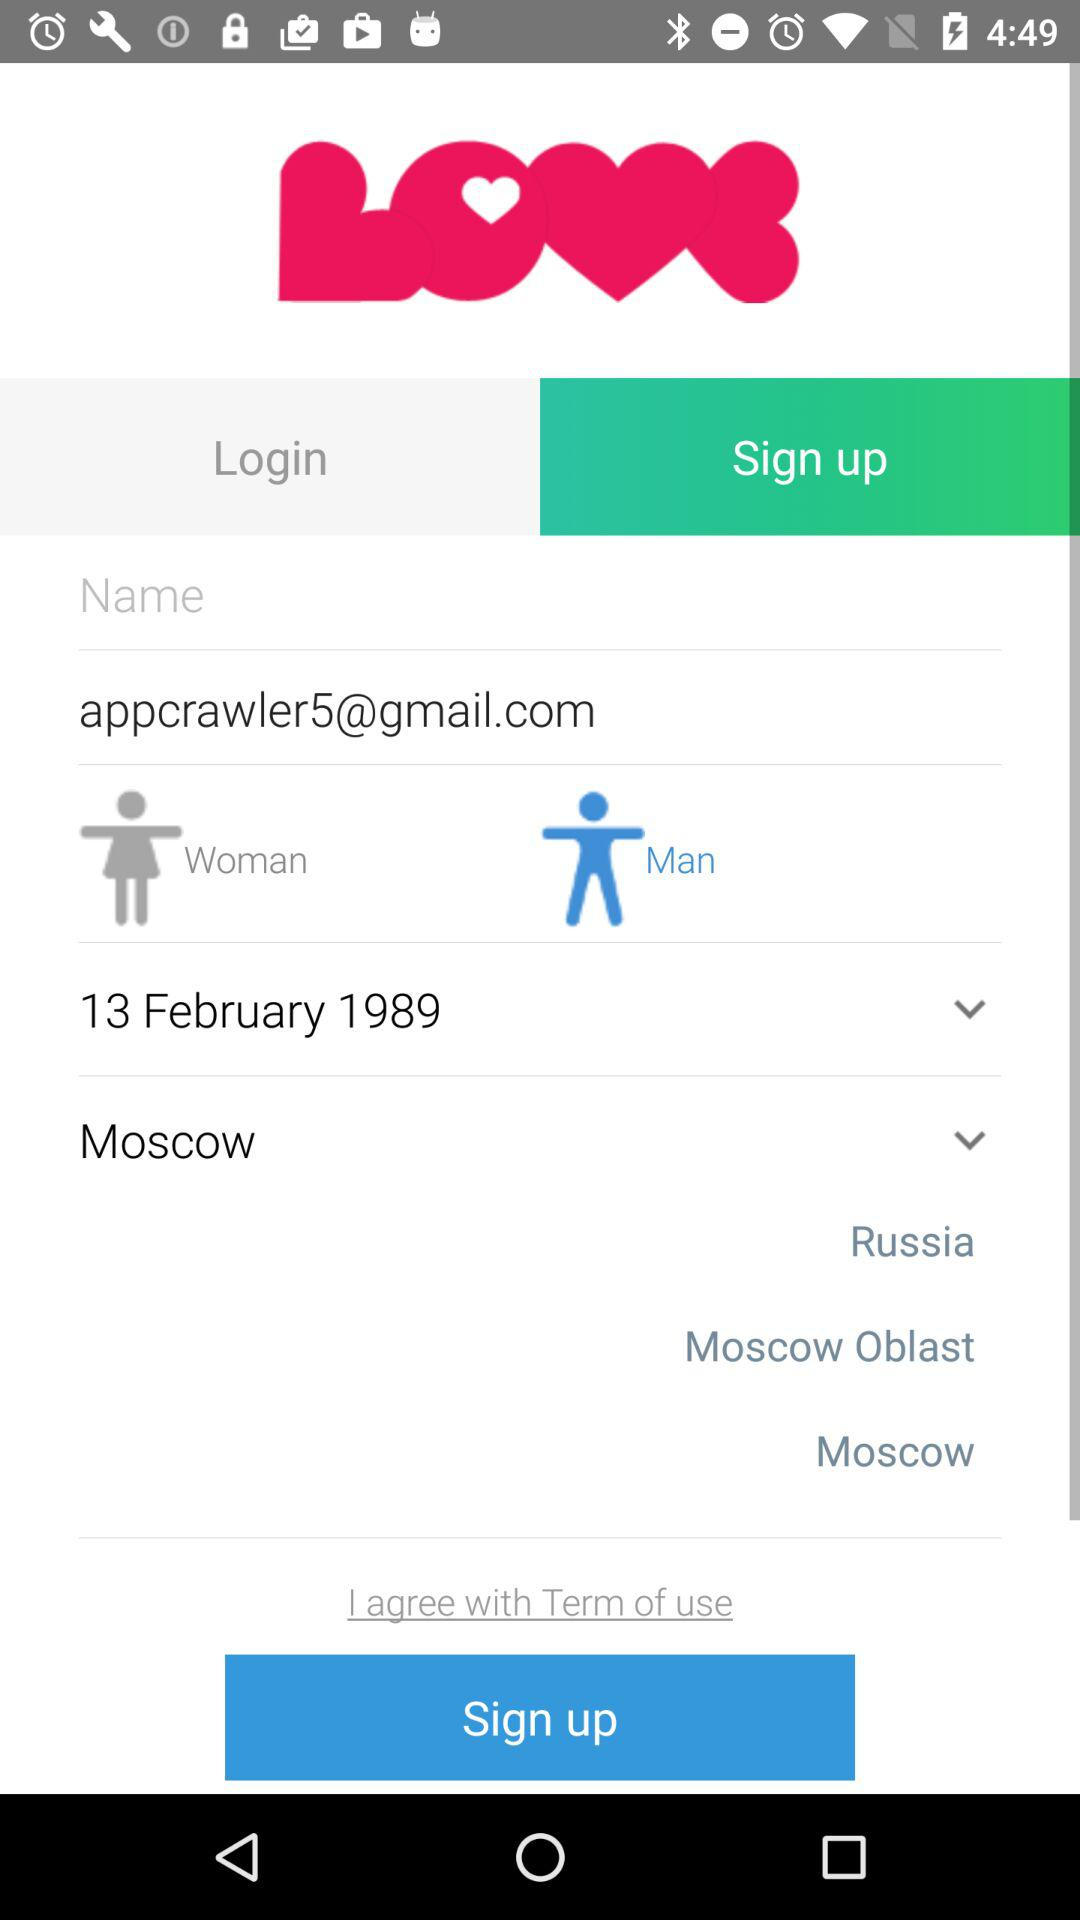Which gender is selected? The selected gender is man. 